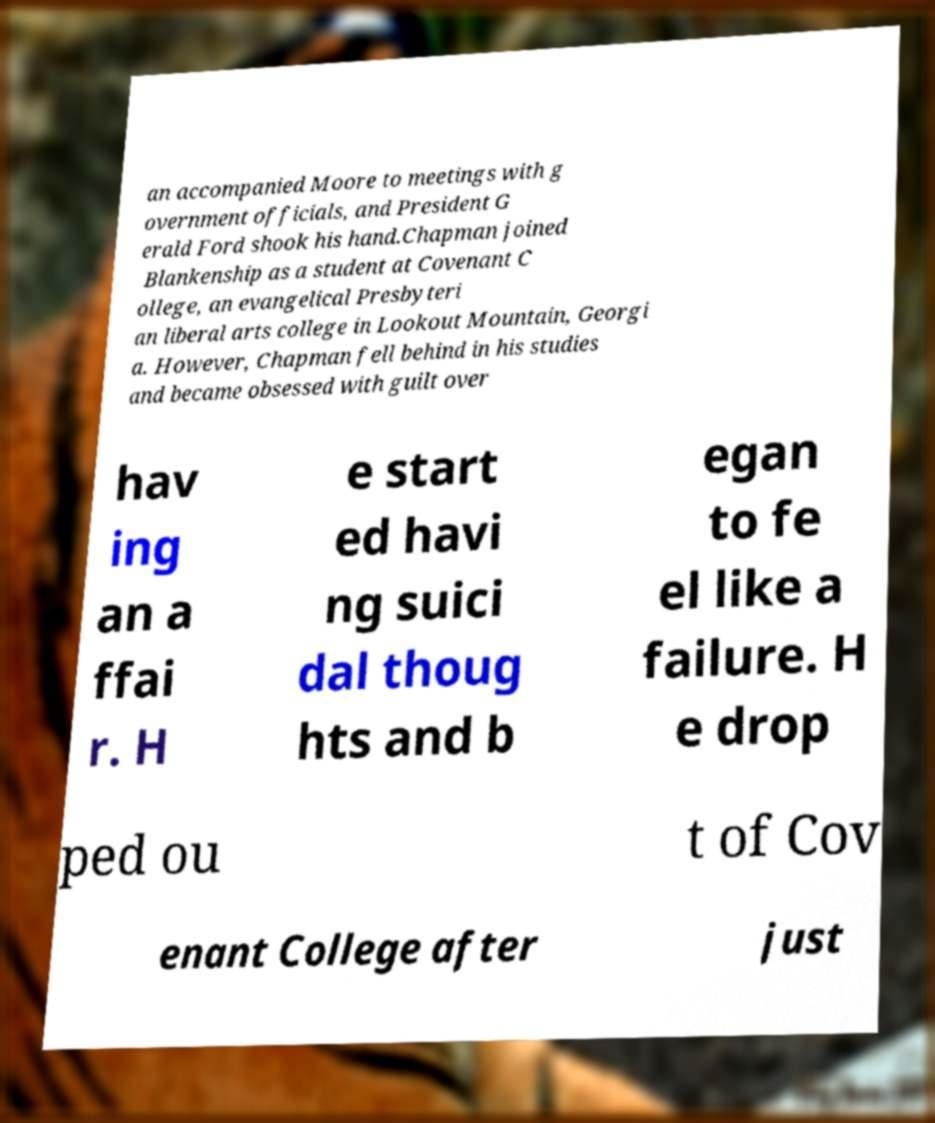For documentation purposes, I need the text within this image transcribed. Could you provide that? an accompanied Moore to meetings with g overnment officials, and President G erald Ford shook his hand.Chapman joined Blankenship as a student at Covenant C ollege, an evangelical Presbyteri an liberal arts college in Lookout Mountain, Georgi a. However, Chapman fell behind in his studies and became obsessed with guilt over hav ing an a ffai r. H e start ed havi ng suici dal thoug hts and b egan to fe el like a failure. H e drop ped ou t of Cov enant College after just 